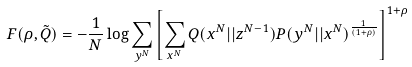Convert formula to latex. <formula><loc_0><loc_0><loc_500><loc_500>F ( \rho , \tilde { Q } ) = - \frac { 1 } { N } \log \sum _ { y ^ { N } } \left [ \sum _ { x ^ { N } } Q ( x ^ { N } | | z ^ { N - 1 } ) P ( y ^ { N } | | x ^ { N } ) ^ { \frac { 1 } { ( 1 + \rho ) } } \right ] ^ { 1 + \rho }</formula> 